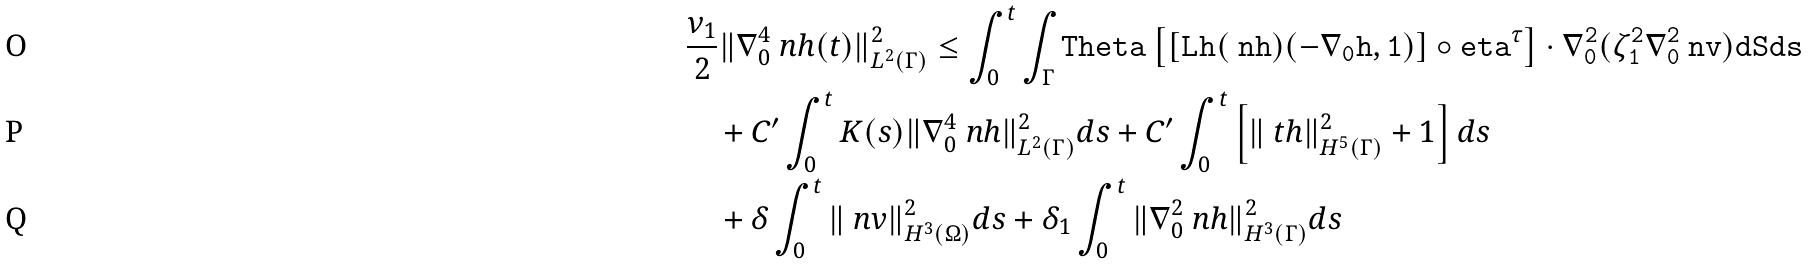Convert formula to latex. <formula><loc_0><loc_0><loc_500><loc_500>& \frac { \nu _ { 1 } } { 2 } \| \nabla _ { 0 } ^ { 4 } \ n h ( t ) \| ^ { 2 } _ { L ^ { 2 } ( \Gamma ) } \leq \int _ { 0 } ^ { t } \int _ { \Gamma } \tt T h e t a \left [ [ L _ { \tt } h ( \ n h ) ( - \nabla _ { 0 } \tt h , 1 ) ] \circ \tt e t a ^ { \tau } \right ] \cdot \nabla _ { 0 } ^ { 2 } ( \zeta _ { 1 } ^ { 2 } \nabla _ { 0 } ^ { 2 } \ n v ) d S d s \\ & \quad + C ^ { \prime } \int _ { 0 } ^ { t } K ( s ) \| \nabla _ { 0 } ^ { 4 } \ n h \| ^ { 2 } _ { L ^ { 2 } ( \Gamma ) } d s + C ^ { \prime } \int _ { 0 } ^ { t } \left [ \| \ t h \| ^ { 2 } _ { H ^ { 5 } ( \Gamma ) } + 1 \right ] d s \\ & \quad + \delta \int _ { 0 } ^ { t } \| \ n v \| ^ { 2 } _ { H ^ { 3 } ( \Omega ) } d s + \delta _ { 1 } \int _ { 0 } ^ { t } \| \nabla _ { 0 } ^ { 2 } \ n h \| ^ { 2 } _ { H ^ { 3 } ( \Gamma ) } d s</formula> 